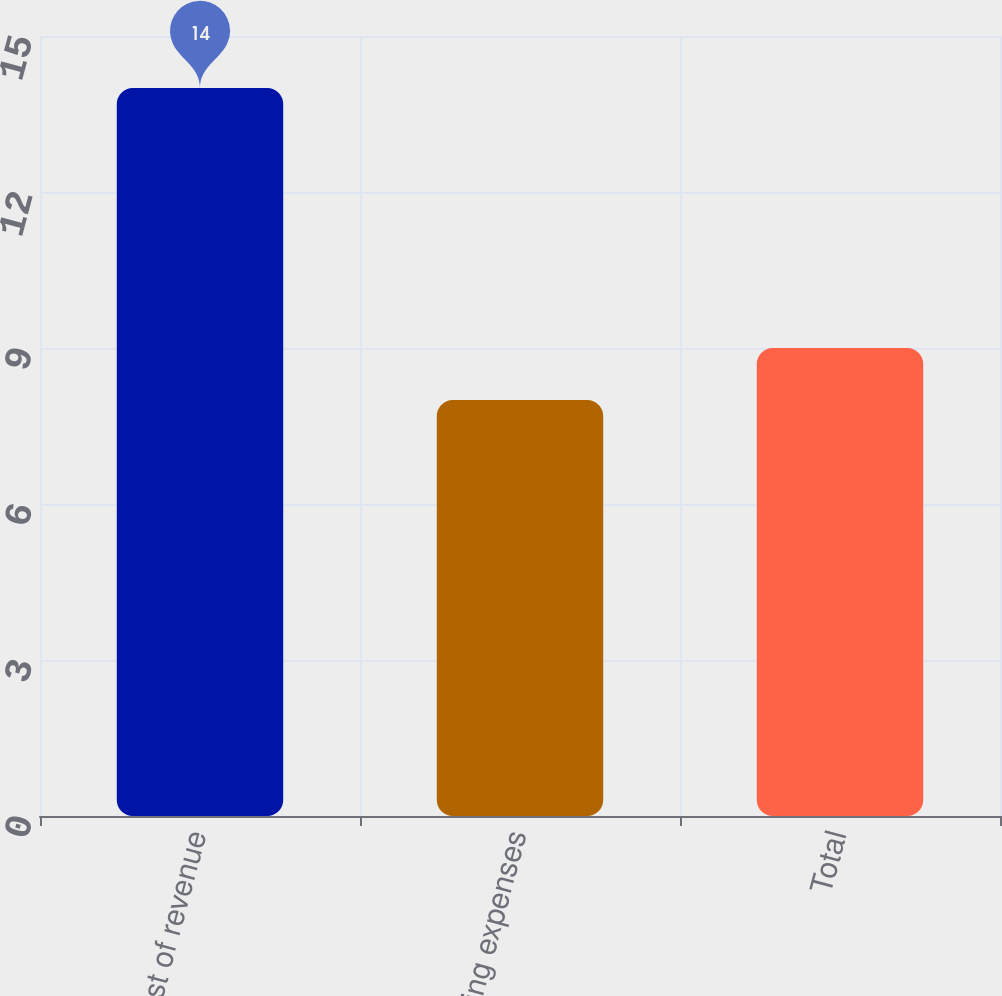Convert chart to OTSL. <chart><loc_0><loc_0><loc_500><loc_500><bar_chart><fcel>Cost of revenue<fcel>Operating expenses<fcel>Total<nl><fcel>14<fcel>8<fcel>9<nl></chart> 